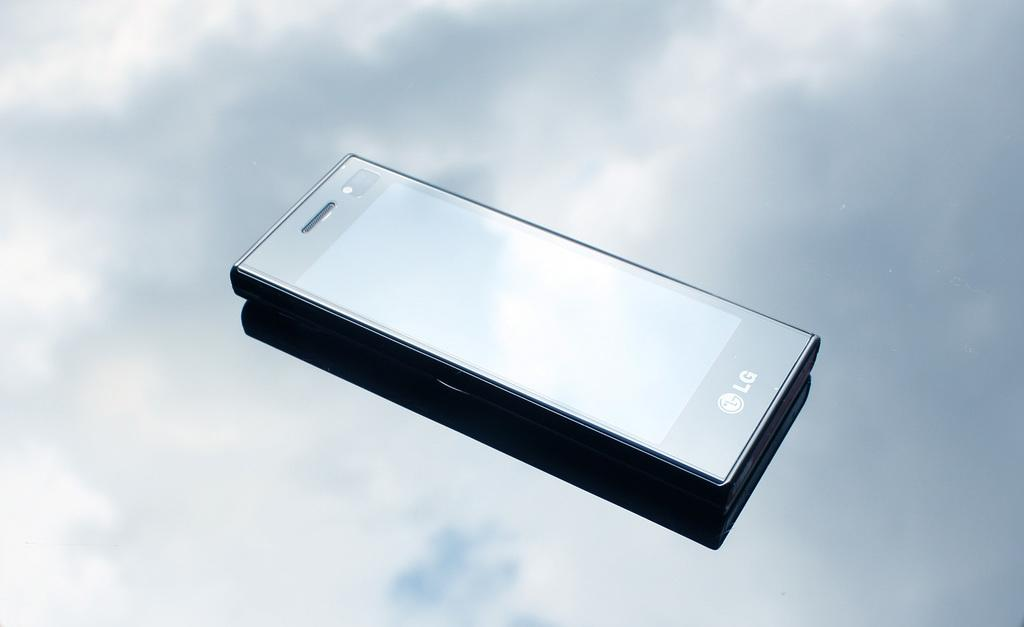<image>
Summarize the visual content of the image. A boxy LG phone against a sky background. 